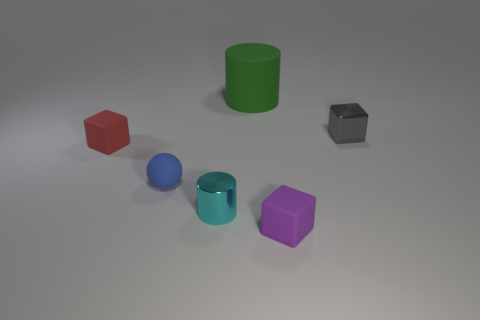What shape is the metallic object in front of the matte block that is behind the small metal cylinder?
Your response must be concise. Cylinder. Is the number of green rubber cylinders less than the number of objects?
Give a very brief answer. Yes. Do the cyan object and the green cylinder have the same material?
Ensure brevity in your answer.  No. There is a rubber object that is both right of the small cyan cylinder and to the left of the purple rubber object; what color is it?
Your response must be concise. Green. Are there any cylinders that have the same size as the blue thing?
Provide a short and direct response. Yes. There is a object that is to the right of the tiny matte cube that is to the right of the large cylinder; what is its size?
Provide a short and direct response. Small. Are there fewer small blue matte balls that are behind the gray shiny object than tiny rubber objects?
Make the answer very short. Yes. Do the large cylinder and the rubber ball have the same color?
Your response must be concise. No. What is the size of the cyan object?
Your response must be concise. Small. There is a matte object that is behind the block that is on the right side of the small purple block; is there a small rubber thing in front of it?
Your response must be concise. Yes. 